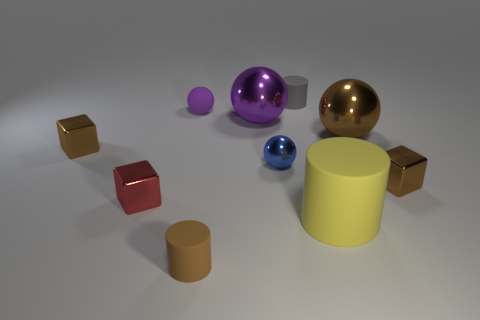Subtract all brown shiny blocks. How many blocks are left? 1 Subtract 1 cubes. How many cubes are left? 2 Subtract all brown balls. How many balls are left? 3 Subtract all green balls. Subtract all cyan cylinders. How many balls are left? 4 Subtract all cylinders. How many objects are left? 7 Add 3 small yellow rubber things. How many small yellow rubber things exist? 3 Subtract 0 purple blocks. How many objects are left? 10 Subtract all large gray matte spheres. Subtract all brown things. How many objects are left? 6 Add 2 tiny metal spheres. How many tiny metal spheres are left? 3 